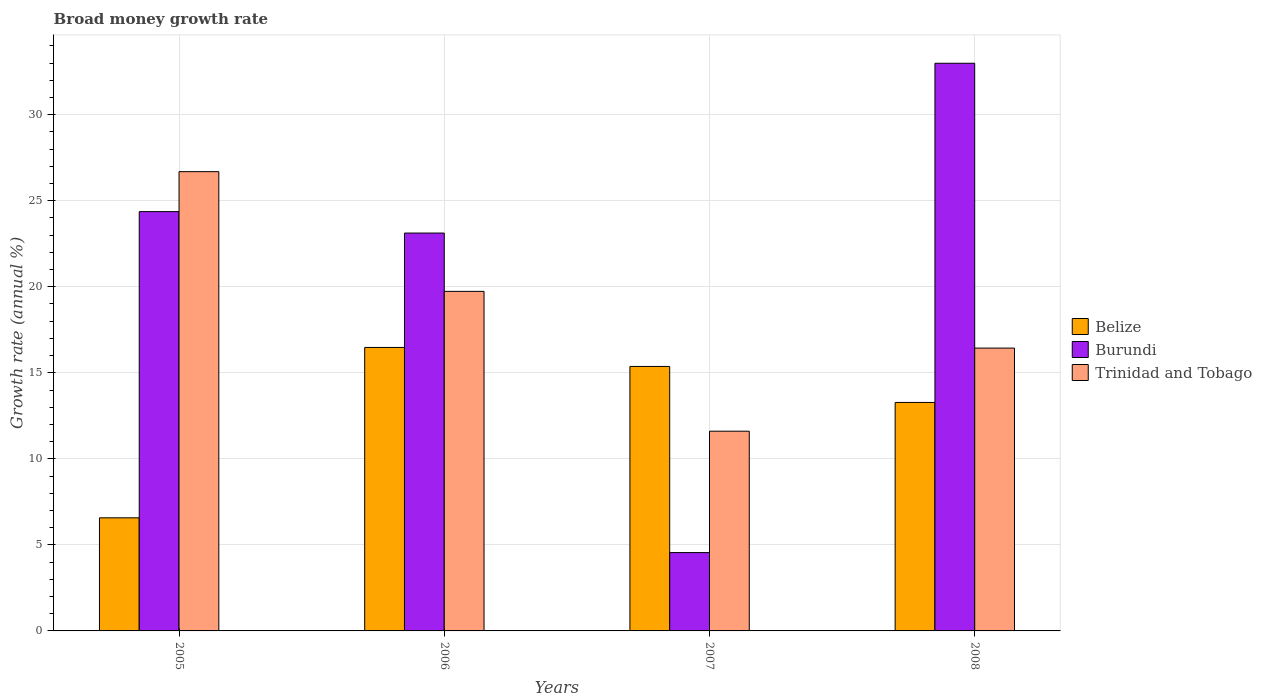How many different coloured bars are there?
Your response must be concise. 3. What is the label of the 2nd group of bars from the left?
Keep it short and to the point. 2006. What is the growth rate in Burundi in 2008?
Provide a short and direct response. 32.99. Across all years, what is the maximum growth rate in Burundi?
Give a very brief answer. 32.99. Across all years, what is the minimum growth rate in Belize?
Your response must be concise. 6.57. In which year was the growth rate in Belize maximum?
Provide a succinct answer. 2006. What is the total growth rate in Burundi in the graph?
Offer a terse response. 85.04. What is the difference between the growth rate in Belize in 2006 and that in 2008?
Your answer should be compact. 3.2. What is the difference between the growth rate in Trinidad and Tobago in 2008 and the growth rate in Burundi in 2007?
Your answer should be very brief. 11.88. What is the average growth rate in Trinidad and Tobago per year?
Give a very brief answer. 18.62. In the year 2008, what is the difference between the growth rate in Burundi and growth rate in Trinidad and Tobago?
Provide a succinct answer. 16.55. In how many years, is the growth rate in Belize greater than 5 %?
Offer a very short reply. 4. What is the ratio of the growth rate in Belize in 2005 to that in 2007?
Give a very brief answer. 0.43. What is the difference between the highest and the second highest growth rate in Belize?
Ensure brevity in your answer.  1.1. What is the difference between the highest and the lowest growth rate in Belize?
Your answer should be compact. 9.9. In how many years, is the growth rate in Belize greater than the average growth rate in Belize taken over all years?
Make the answer very short. 3. What does the 2nd bar from the left in 2007 represents?
Provide a succinct answer. Burundi. What does the 3rd bar from the right in 2005 represents?
Provide a succinct answer. Belize. How many bars are there?
Your response must be concise. 12. Are all the bars in the graph horizontal?
Provide a short and direct response. No. What is the difference between two consecutive major ticks on the Y-axis?
Make the answer very short. 5. Does the graph contain any zero values?
Your answer should be very brief. No. Where does the legend appear in the graph?
Offer a terse response. Center right. How many legend labels are there?
Provide a short and direct response. 3. What is the title of the graph?
Make the answer very short. Broad money growth rate. Does "Mexico" appear as one of the legend labels in the graph?
Make the answer very short. No. What is the label or title of the Y-axis?
Your answer should be compact. Growth rate (annual %). What is the Growth rate (annual %) in Belize in 2005?
Offer a very short reply. 6.57. What is the Growth rate (annual %) in Burundi in 2005?
Offer a very short reply. 24.37. What is the Growth rate (annual %) in Trinidad and Tobago in 2005?
Make the answer very short. 26.69. What is the Growth rate (annual %) of Belize in 2006?
Your response must be concise. 16.48. What is the Growth rate (annual %) in Burundi in 2006?
Ensure brevity in your answer.  23.12. What is the Growth rate (annual %) of Trinidad and Tobago in 2006?
Your answer should be very brief. 19.73. What is the Growth rate (annual %) in Belize in 2007?
Ensure brevity in your answer.  15.37. What is the Growth rate (annual %) in Burundi in 2007?
Ensure brevity in your answer.  4.55. What is the Growth rate (annual %) in Trinidad and Tobago in 2007?
Your response must be concise. 11.61. What is the Growth rate (annual %) of Belize in 2008?
Provide a short and direct response. 13.28. What is the Growth rate (annual %) in Burundi in 2008?
Provide a succinct answer. 32.99. What is the Growth rate (annual %) in Trinidad and Tobago in 2008?
Give a very brief answer. 16.44. Across all years, what is the maximum Growth rate (annual %) of Belize?
Give a very brief answer. 16.48. Across all years, what is the maximum Growth rate (annual %) in Burundi?
Give a very brief answer. 32.99. Across all years, what is the maximum Growth rate (annual %) of Trinidad and Tobago?
Your response must be concise. 26.69. Across all years, what is the minimum Growth rate (annual %) in Belize?
Give a very brief answer. 6.57. Across all years, what is the minimum Growth rate (annual %) of Burundi?
Your answer should be very brief. 4.55. Across all years, what is the minimum Growth rate (annual %) in Trinidad and Tobago?
Your response must be concise. 11.61. What is the total Growth rate (annual %) of Belize in the graph?
Provide a succinct answer. 51.7. What is the total Growth rate (annual %) in Burundi in the graph?
Give a very brief answer. 85.04. What is the total Growth rate (annual %) of Trinidad and Tobago in the graph?
Offer a terse response. 74.47. What is the difference between the Growth rate (annual %) in Belize in 2005 and that in 2006?
Give a very brief answer. -9.9. What is the difference between the Growth rate (annual %) of Burundi in 2005 and that in 2006?
Offer a very short reply. 1.25. What is the difference between the Growth rate (annual %) in Trinidad and Tobago in 2005 and that in 2006?
Offer a very short reply. 6.96. What is the difference between the Growth rate (annual %) of Belize in 2005 and that in 2007?
Ensure brevity in your answer.  -8.8. What is the difference between the Growth rate (annual %) of Burundi in 2005 and that in 2007?
Your response must be concise. 19.82. What is the difference between the Growth rate (annual %) in Trinidad and Tobago in 2005 and that in 2007?
Your answer should be compact. 15.08. What is the difference between the Growth rate (annual %) in Belize in 2005 and that in 2008?
Your response must be concise. -6.71. What is the difference between the Growth rate (annual %) in Burundi in 2005 and that in 2008?
Keep it short and to the point. -8.62. What is the difference between the Growth rate (annual %) of Trinidad and Tobago in 2005 and that in 2008?
Offer a very short reply. 10.25. What is the difference between the Growth rate (annual %) in Belize in 2006 and that in 2007?
Make the answer very short. 1.1. What is the difference between the Growth rate (annual %) in Burundi in 2006 and that in 2007?
Offer a very short reply. 18.57. What is the difference between the Growth rate (annual %) in Trinidad and Tobago in 2006 and that in 2007?
Provide a short and direct response. 8.13. What is the difference between the Growth rate (annual %) of Belize in 2006 and that in 2008?
Your answer should be very brief. 3.2. What is the difference between the Growth rate (annual %) of Burundi in 2006 and that in 2008?
Your answer should be compact. -9.87. What is the difference between the Growth rate (annual %) in Trinidad and Tobago in 2006 and that in 2008?
Make the answer very short. 3.3. What is the difference between the Growth rate (annual %) in Belize in 2007 and that in 2008?
Offer a very short reply. 2.09. What is the difference between the Growth rate (annual %) in Burundi in 2007 and that in 2008?
Keep it short and to the point. -28.44. What is the difference between the Growth rate (annual %) of Trinidad and Tobago in 2007 and that in 2008?
Your answer should be very brief. -4.83. What is the difference between the Growth rate (annual %) in Belize in 2005 and the Growth rate (annual %) in Burundi in 2006?
Your response must be concise. -16.55. What is the difference between the Growth rate (annual %) in Belize in 2005 and the Growth rate (annual %) in Trinidad and Tobago in 2006?
Provide a succinct answer. -13.16. What is the difference between the Growth rate (annual %) in Burundi in 2005 and the Growth rate (annual %) in Trinidad and Tobago in 2006?
Your answer should be compact. 4.63. What is the difference between the Growth rate (annual %) in Belize in 2005 and the Growth rate (annual %) in Burundi in 2007?
Provide a succinct answer. 2.02. What is the difference between the Growth rate (annual %) of Belize in 2005 and the Growth rate (annual %) of Trinidad and Tobago in 2007?
Offer a very short reply. -5.03. What is the difference between the Growth rate (annual %) of Burundi in 2005 and the Growth rate (annual %) of Trinidad and Tobago in 2007?
Your answer should be very brief. 12.76. What is the difference between the Growth rate (annual %) of Belize in 2005 and the Growth rate (annual %) of Burundi in 2008?
Provide a succinct answer. -26.42. What is the difference between the Growth rate (annual %) of Belize in 2005 and the Growth rate (annual %) of Trinidad and Tobago in 2008?
Give a very brief answer. -9.86. What is the difference between the Growth rate (annual %) of Burundi in 2005 and the Growth rate (annual %) of Trinidad and Tobago in 2008?
Your response must be concise. 7.93. What is the difference between the Growth rate (annual %) of Belize in 2006 and the Growth rate (annual %) of Burundi in 2007?
Your answer should be compact. 11.92. What is the difference between the Growth rate (annual %) in Belize in 2006 and the Growth rate (annual %) in Trinidad and Tobago in 2007?
Your answer should be compact. 4.87. What is the difference between the Growth rate (annual %) in Burundi in 2006 and the Growth rate (annual %) in Trinidad and Tobago in 2007?
Provide a short and direct response. 11.52. What is the difference between the Growth rate (annual %) of Belize in 2006 and the Growth rate (annual %) of Burundi in 2008?
Provide a short and direct response. -16.52. What is the difference between the Growth rate (annual %) in Belize in 2006 and the Growth rate (annual %) in Trinidad and Tobago in 2008?
Your response must be concise. 0.04. What is the difference between the Growth rate (annual %) of Burundi in 2006 and the Growth rate (annual %) of Trinidad and Tobago in 2008?
Your answer should be compact. 6.69. What is the difference between the Growth rate (annual %) of Belize in 2007 and the Growth rate (annual %) of Burundi in 2008?
Provide a short and direct response. -17.62. What is the difference between the Growth rate (annual %) of Belize in 2007 and the Growth rate (annual %) of Trinidad and Tobago in 2008?
Offer a very short reply. -1.07. What is the difference between the Growth rate (annual %) in Burundi in 2007 and the Growth rate (annual %) in Trinidad and Tobago in 2008?
Your answer should be very brief. -11.88. What is the average Growth rate (annual %) of Belize per year?
Make the answer very short. 12.92. What is the average Growth rate (annual %) of Burundi per year?
Offer a very short reply. 21.26. What is the average Growth rate (annual %) in Trinidad and Tobago per year?
Provide a short and direct response. 18.62. In the year 2005, what is the difference between the Growth rate (annual %) in Belize and Growth rate (annual %) in Burundi?
Your answer should be very brief. -17.8. In the year 2005, what is the difference between the Growth rate (annual %) in Belize and Growth rate (annual %) in Trinidad and Tobago?
Your response must be concise. -20.12. In the year 2005, what is the difference between the Growth rate (annual %) in Burundi and Growth rate (annual %) in Trinidad and Tobago?
Your response must be concise. -2.32. In the year 2006, what is the difference between the Growth rate (annual %) in Belize and Growth rate (annual %) in Burundi?
Make the answer very short. -6.65. In the year 2006, what is the difference between the Growth rate (annual %) of Belize and Growth rate (annual %) of Trinidad and Tobago?
Your response must be concise. -3.26. In the year 2006, what is the difference between the Growth rate (annual %) in Burundi and Growth rate (annual %) in Trinidad and Tobago?
Ensure brevity in your answer.  3.39. In the year 2007, what is the difference between the Growth rate (annual %) in Belize and Growth rate (annual %) in Burundi?
Provide a succinct answer. 10.82. In the year 2007, what is the difference between the Growth rate (annual %) in Belize and Growth rate (annual %) in Trinidad and Tobago?
Provide a short and direct response. 3.76. In the year 2007, what is the difference between the Growth rate (annual %) in Burundi and Growth rate (annual %) in Trinidad and Tobago?
Offer a terse response. -7.05. In the year 2008, what is the difference between the Growth rate (annual %) of Belize and Growth rate (annual %) of Burundi?
Provide a succinct answer. -19.71. In the year 2008, what is the difference between the Growth rate (annual %) in Belize and Growth rate (annual %) in Trinidad and Tobago?
Ensure brevity in your answer.  -3.16. In the year 2008, what is the difference between the Growth rate (annual %) in Burundi and Growth rate (annual %) in Trinidad and Tobago?
Keep it short and to the point. 16.55. What is the ratio of the Growth rate (annual %) in Belize in 2005 to that in 2006?
Your answer should be compact. 0.4. What is the ratio of the Growth rate (annual %) in Burundi in 2005 to that in 2006?
Offer a terse response. 1.05. What is the ratio of the Growth rate (annual %) of Trinidad and Tobago in 2005 to that in 2006?
Offer a terse response. 1.35. What is the ratio of the Growth rate (annual %) in Belize in 2005 to that in 2007?
Provide a succinct answer. 0.43. What is the ratio of the Growth rate (annual %) in Burundi in 2005 to that in 2007?
Make the answer very short. 5.35. What is the ratio of the Growth rate (annual %) of Trinidad and Tobago in 2005 to that in 2007?
Make the answer very short. 2.3. What is the ratio of the Growth rate (annual %) in Belize in 2005 to that in 2008?
Offer a very short reply. 0.49. What is the ratio of the Growth rate (annual %) in Burundi in 2005 to that in 2008?
Your answer should be compact. 0.74. What is the ratio of the Growth rate (annual %) of Trinidad and Tobago in 2005 to that in 2008?
Keep it short and to the point. 1.62. What is the ratio of the Growth rate (annual %) of Belize in 2006 to that in 2007?
Offer a very short reply. 1.07. What is the ratio of the Growth rate (annual %) of Burundi in 2006 to that in 2007?
Offer a terse response. 5.08. What is the ratio of the Growth rate (annual %) in Trinidad and Tobago in 2006 to that in 2007?
Your answer should be compact. 1.7. What is the ratio of the Growth rate (annual %) in Belize in 2006 to that in 2008?
Give a very brief answer. 1.24. What is the ratio of the Growth rate (annual %) of Burundi in 2006 to that in 2008?
Your answer should be compact. 0.7. What is the ratio of the Growth rate (annual %) of Trinidad and Tobago in 2006 to that in 2008?
Your answer should be very brief. 1.2. What is the ratio of the Growth rate (annual %) of Belize in 2007 to that in 2008?
Your answer should be very brief. 1.16. What is the ratio of the Growth rate (annual %) of Burundi in 2007 to that in 2008?
Your answer should be very brief. 0.14. What is the ratio of the Growth rate (annual %) of Trinidad and Tobago in 2007 to that in 2008?
Offer a very short reply. 0.71. What is the difference between the highest and the second highest Growth rate (annual %) in Belize?
Your response must be concise. 1.1. What is the difference between the highest and the second highest Growth rate (annual %) of Burundi?
Make the answer very short. 8.62. What is the difference between the highest and the second highest Growth rate (annual %) of Trinidad and Tobago?
Provide a succinct answer. 6.96. What is the difference between the highest and the lowest Growth rate (annual %) in Belize?
Your answer should be very brief. 9.9. What is the difference between the highest and the lowest Growth rate (annual %) of Burundi?
Ensure brevity in your answer.  28.44. What is the difference between the highest and the lowest Growth rate (annual %) of Trinidad and Tobago?
Give a very brief answer. 15.08. 